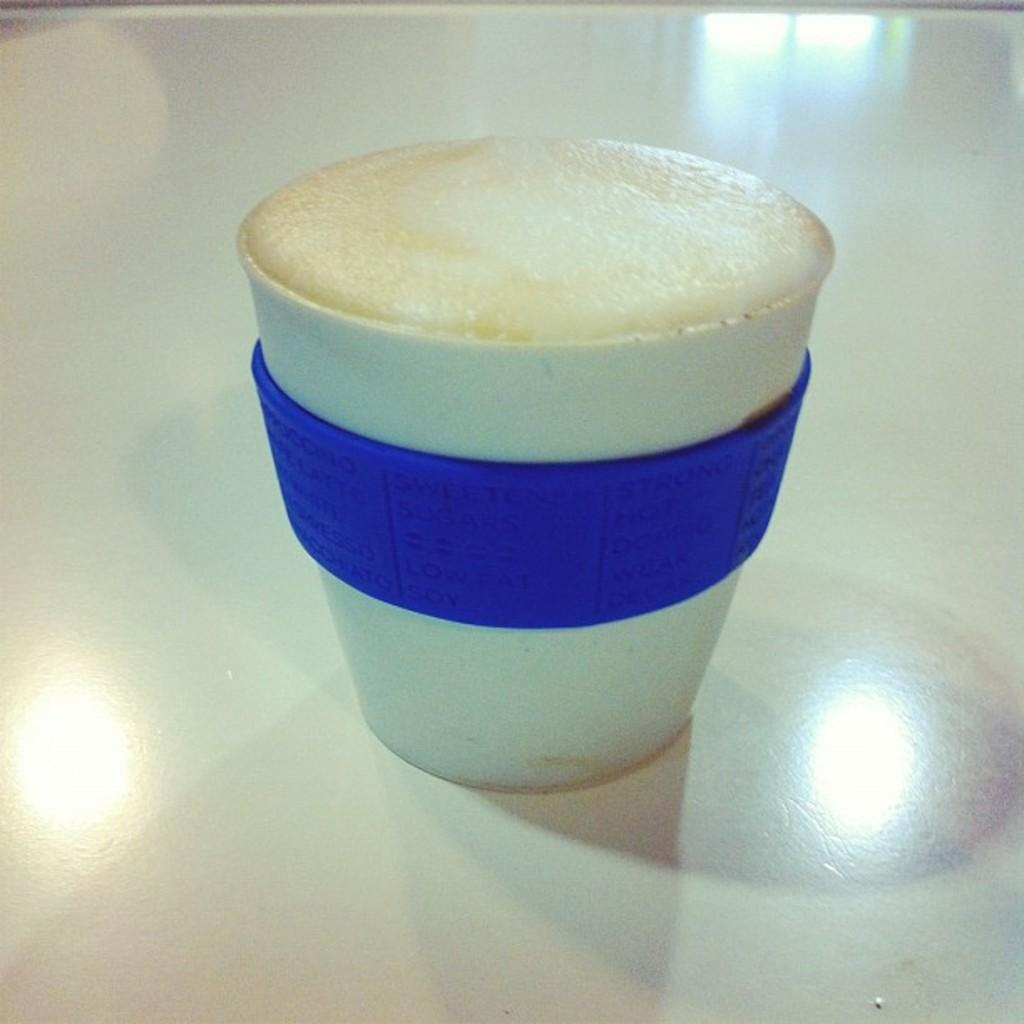What is the color of the surface in the image? The surface in the image is white. What object is placed on the surface? There is a cup on the surface. What are the colors of the cup? The cup is white and blue in color. What is inside the cup? There is a liquid in the cup. What is the color of the liquid? The liquid is cream in color. How many teeth can be seen in the image? There are no teeth visible in the image. Are there any jellyfish swimming in the liquid inside the cup? There are no jellyfish present in the image; the liquid is cream in color. 